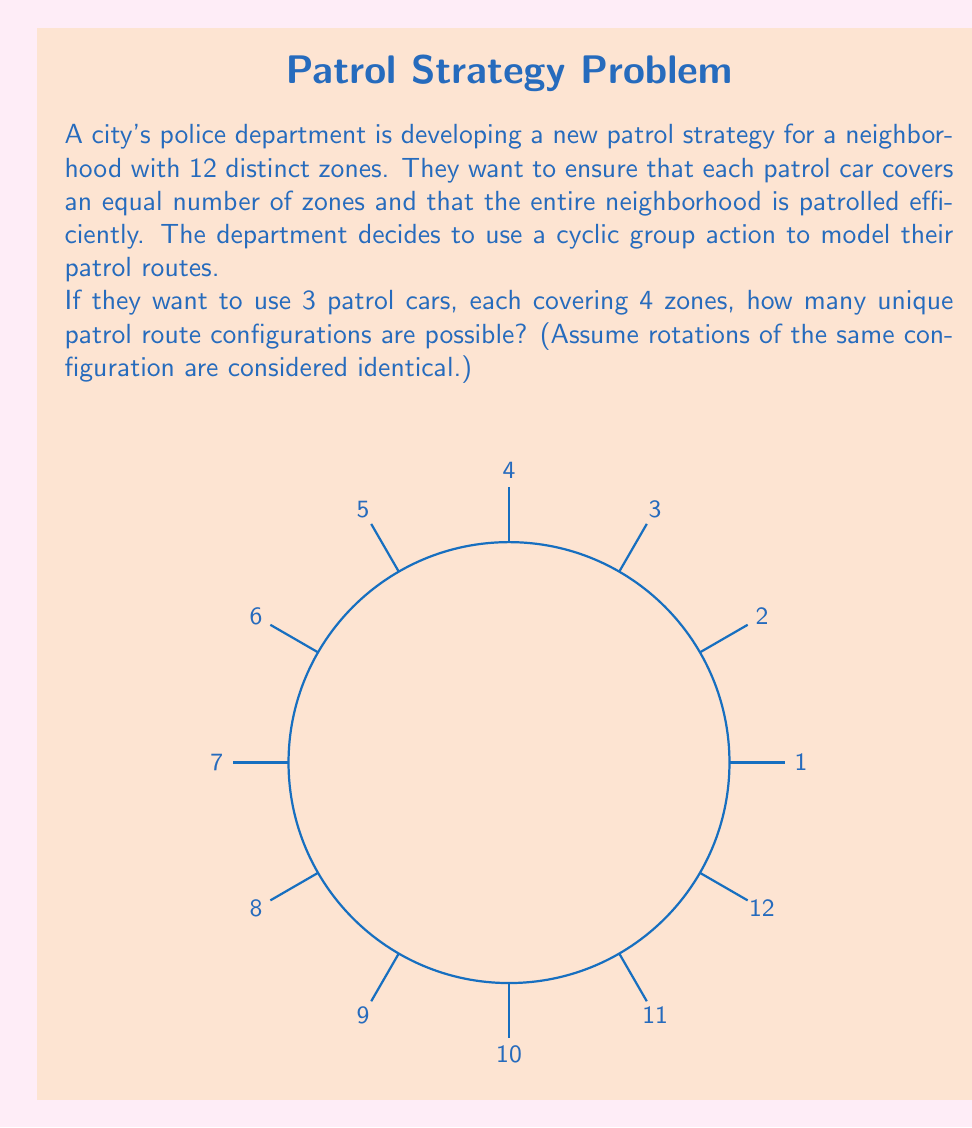Can you answer this question? Let's approach this step-by-step:

1) We are dealing with a cyclic group of order 12, $C_{12}$, representing the 12 zones.

2) We want to partition this group into 3 subsets of size 4 each. This is equivalent to finding the number of orbits under the action of $C_3$ on 4-element subsets of $C_{12}$.

3) To count the number of orbits, we can use Burnside's lemma:

   $$ |X/G| = \frac{1}{|G|} \sum_{g \in G} |X^g| $$

   where $X$ is the set of all possible patrol configurations, $G = C_3$, and $X^g$ is the set of configurations fixed by $g$.

4) $|G| = 3$, corresponding to the identity and two rotations by 4 and 8 zones.

5) For the identity element, all configurations are fixed. The number of ways to choose 4 zones out of 12 is $\binom{12}{4} = 495$.

6) For rotations by 4 and 8 zones, a configuration is fixed only if it's invariant under these rotations. This means the configuration must consist of 3 identical blocks of 4 consecutive zones. There is only 1 such configuration.

7) Applying Burnside's lemma:

   $$ |X/G| = \frac{1}{3} (495 + 1 + 1) = \frac{497}{3} $$

8) Since this must be an integer, we round down to 165.
Answer: 165 